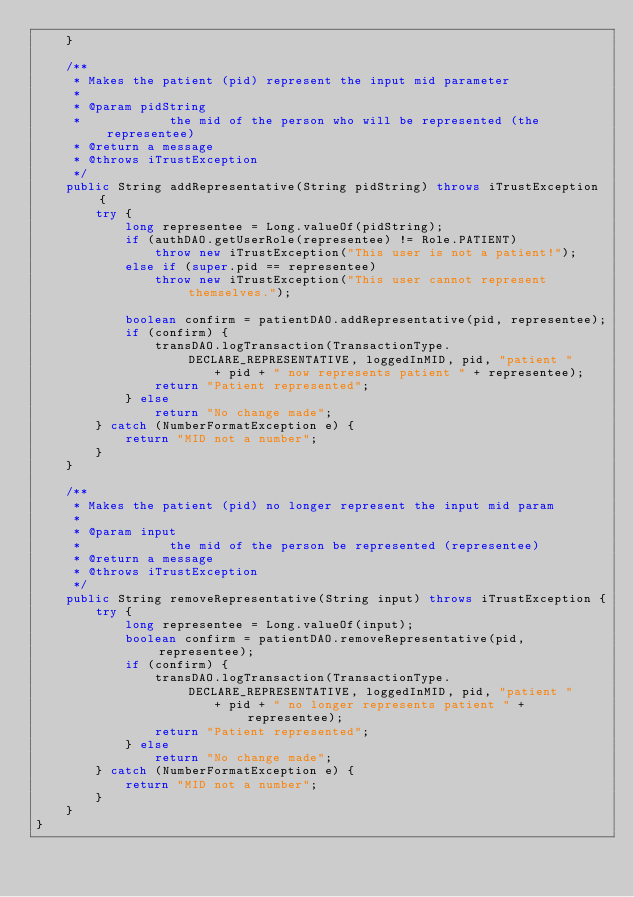<code> <loc_0><loc_0><loc_500><loc_500><_Java_>	}

	/**
	 * Makes the patient (pid) represent the input mid parameter
	 * 
	 * @param pidString
	 *            the mid of the person who will be represented (the representee)
	 * @return a message
	 * @throws iTrustException
	 */
	public String addRepresentative(String pidString) throws iTrustException {
		try {
			long representee = Long.valueOf(pidString);
			if (authDAO.getUserRole(representee) != Role.PATIENT)
				throw new iTrustException("This user is not a patient!");
			else if (super.pid == representee)
				throw new iTrustException("This user cannot represent themselves.");

			boolean confirm = patientDAO.addRepresentative(pid, representee);
			if (confirm) {
				transDAO.logTransaction(TransactionType.DECLARE_REPRESENTATIVE, loggedInMID, pid, "patient "
						+ pid + " now represents patient " + representee);
				return "Patient represented";
			} else
				return "No change made";
		} catch (NumberFormatException e) {
			return "MID not a number";
		}
	}

	/**
	 * Makes the patient (pid) no longer represent the input mid param
	 * 
	 * @param input
	 *            the mid of the person be represented (representee)
	 * @return a message
	 * @throws iTrustException
	 */
	public String removeRepresentative(String input) throws iTrustException {
		try {
			long representee = Long.valueOf(input);
			boolean confirm = patientDAO.removeRepresentative(pid, representee);
			if (confirm) {
				transDAO.logTransaction(TransactionType.DECLARE_REPRESENTATIVE, loggedInMID, pid, "patient "
						+ pid + " no longer represents patient " + representee);
				return "Patient represented";
			} else
				return "No change made";
		} catch (NumberFormatException e) {
			return "MID not a number";
		}
	}
}
</code> 